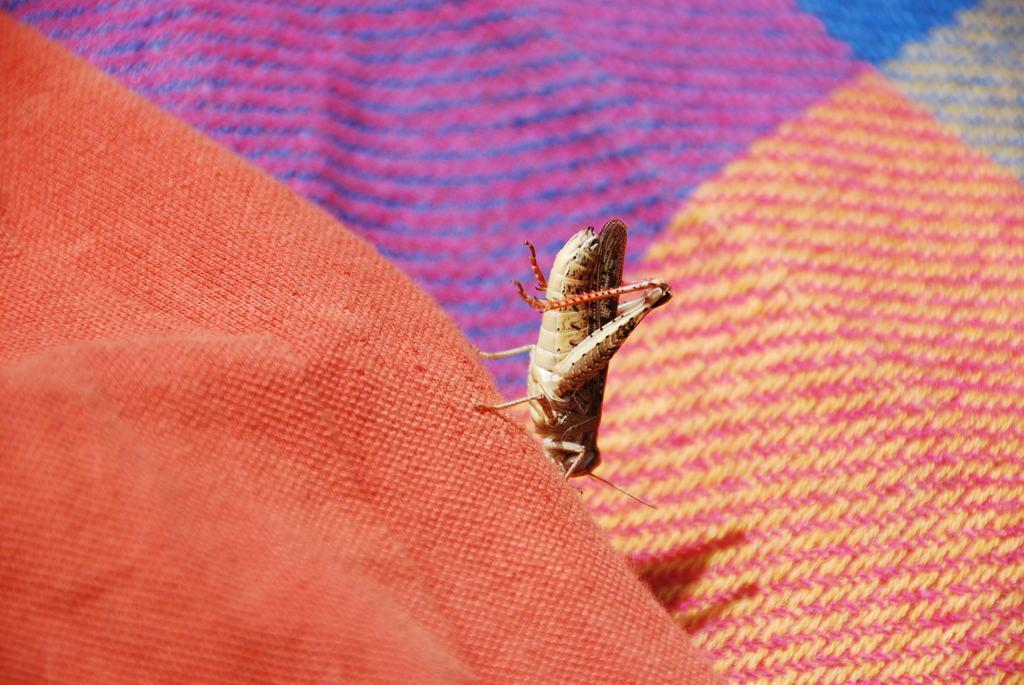Describe this image in one or two sentences. In the given picture, We can see a mat and a Grasshopper. 